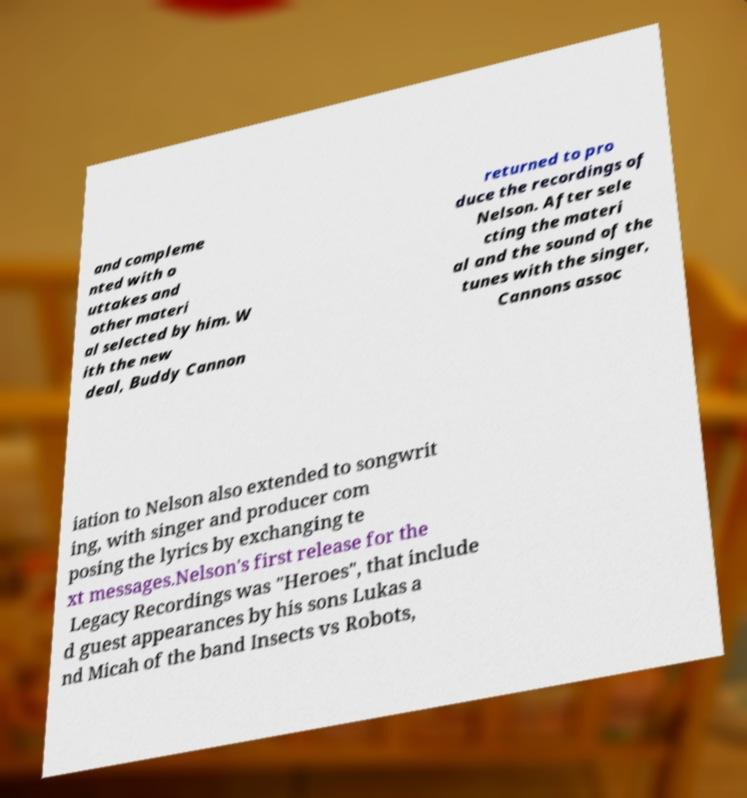Please read and relay the text visible in this image. What does it say? and compleme nted with o uttakes and other materi al selected by him. W ith the new deal, Buddy Cannon returned to pro duce the recordings of Nelson. After sele cting the materi al and the sound of the tunes with the singer, Cannons assoc iation to Nelson also extended to songwrit ing, with singer and producer com posing the lyrics by exchanging te xt messages.Nelson's first release for the Legacy Recordings was "Heroes", that include d guest appearances by his sons Lukas a nd Micah of the band Insects vs Robots, 